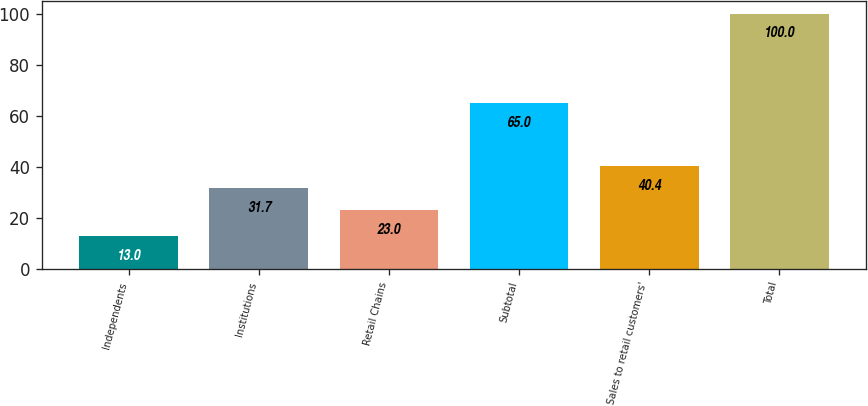Convert chart to OTSL. <chart><loc_0><loc_0><loc_500><loc_500><bar_chart><fcel>Independents<fcel>Institutions<fcel>Retail Chains<fcel>Subtotal<fcel>Sales to retail customers'<fcel>Total<nl><fcel>13<fcel>31.7<fcel>23<fcel>65<fcel>40.4<fcel>100<nl></chart> 